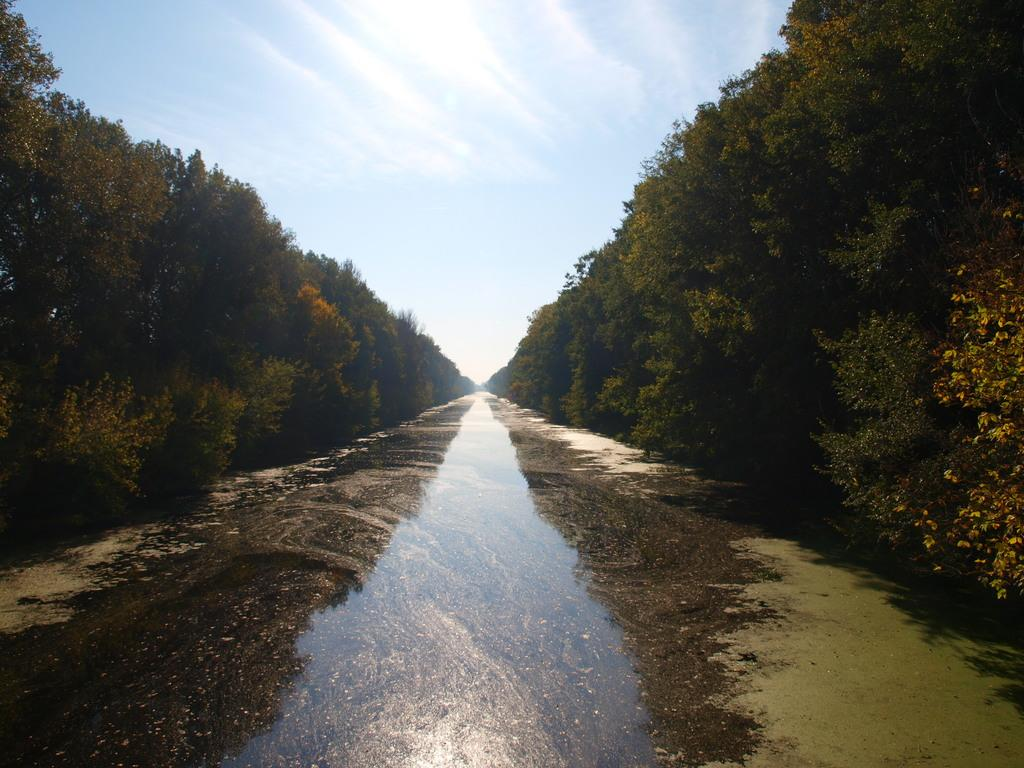What is the primary element in the picture? There is water in the picture. What type of vegetation can be seen in the picture? There are trees in the picture. What can be seen in the background of the picture? The sky is visible in the background of the picture. What type of vegetable is growing near the water in the picture? There is no vegetable present in the image; it only features water and trees. 